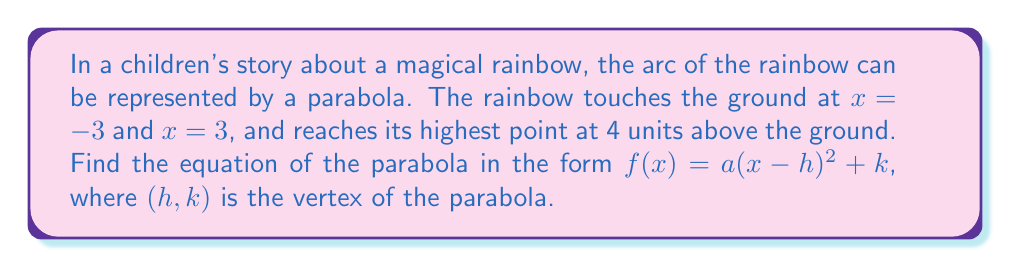What is the answer to this math problem? 1) The parabola is symmetric, so the axis of symmetry is halfway between $x = -3$ and $x = 3$:
   $h = \frac{-3 + 3}{2} = 0$

2) The vertex is the highest point of the parabola, so $k = 4$.

3) We can now write the equation in the form $f(x) = a(x-0)^2 + 4$ or simply $f(x) = ax^2 + 4$.

4) To find $a$, we can use the point $(-3, 0)$ or $(3, 0)$. Let's use $(-3, 0)$:

   $0 = a(-3)^2 + 4$
   $0 = 9a + 4$
   $-4 = 9a$
   $a = -\frac{4}{9}$

5) Therefore, the equation of the parabola is:

   $f(x) = -\frac{4}{9}x^2 + 4$

6) To put this in the requested form $f(x) = a(x-h)^2 + k$:

   $f(x) = -\frac{4}{9}(x-0)^2 + 4$
Answer: $f(x) = -\frac{4}{9}(x-0)^2 + 4$ 